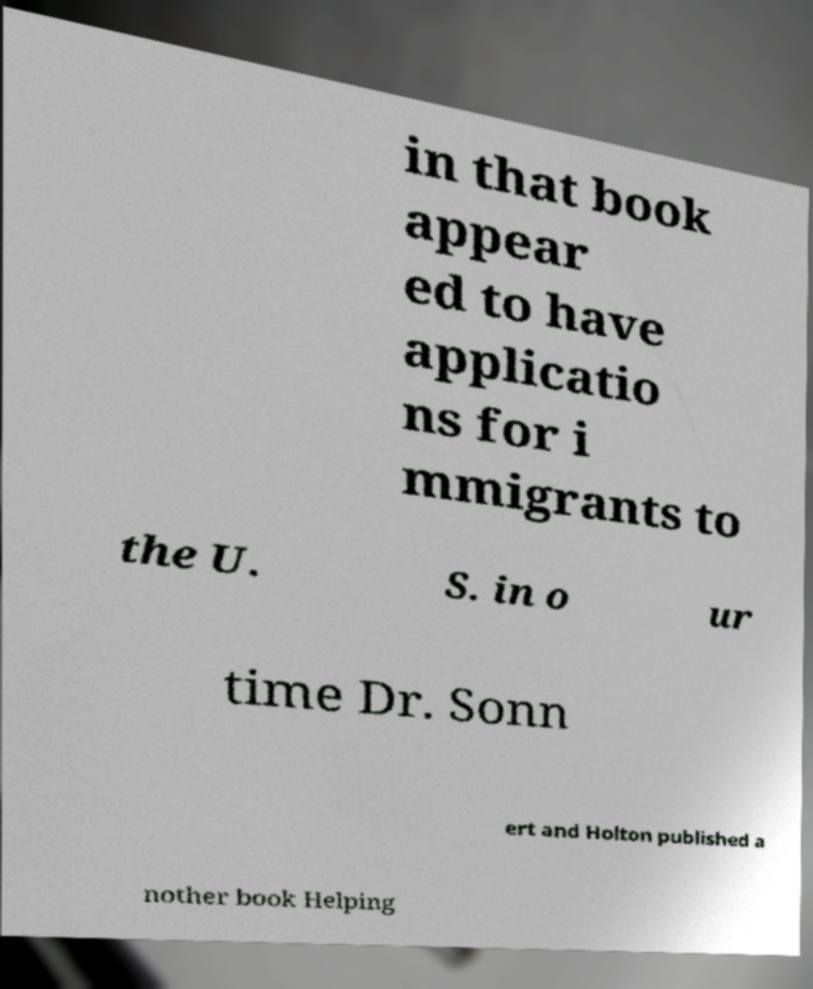Please read and relay the text visible in this image. What does it say? in that book appear ed to have applicatio ns for i mmigrants to the U. S. in o ur time Dr. Sonn ert and Holton published a nother book Helping 